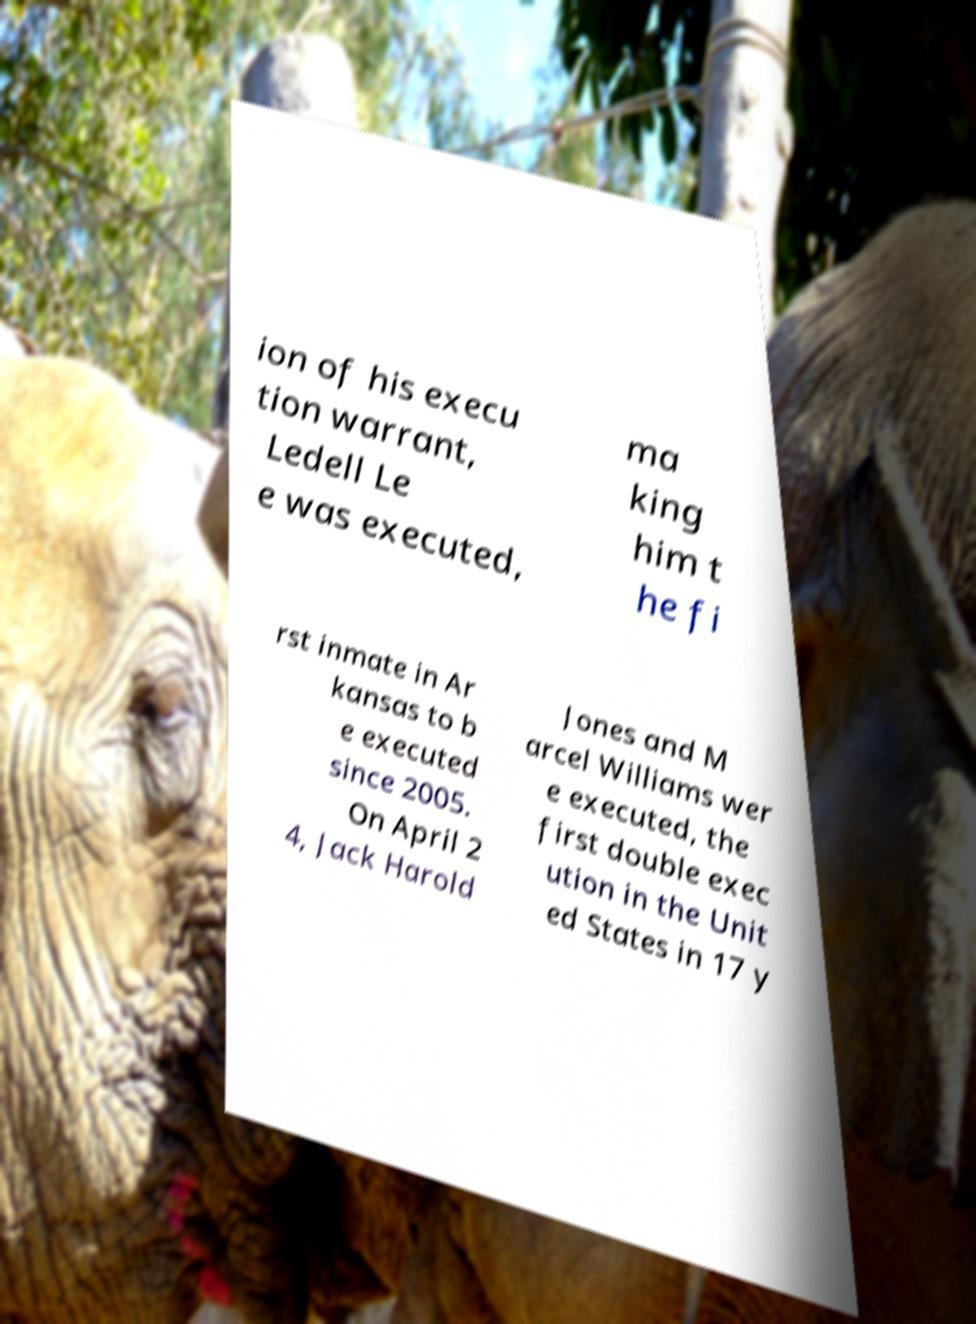Please read and relay the text visible in this image. What does it say? ion of his execu tion warrant, Ledell Le e was executed, ma king him t he fi rst inmate in Ar kansas to b e executed since 2005. On April 2 4, Jack Harold Jones and M arcel Williams wer e executed, the first double exec ution in the Unit ed States in 17 y 